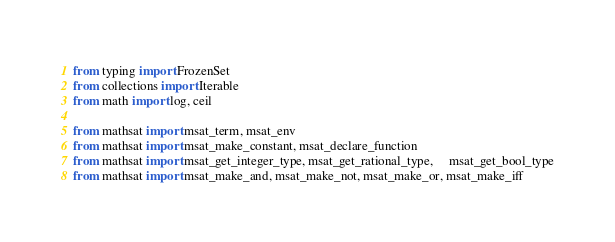Convert code to text. <code><loc_0><loc_0><loc_500><loc_500><_Python_>from typing import FrozenSet
from collections import Iterable
from math import log, ceil

from mathsat import msat_term, msat_env
from mathsat import msat_make_constant, msat_declare_function
from mathsat import msat_get_integer_type, msat_get_rational_type,     msat_get_bool_type
from mathsat import msat_make_and, msat_make_not, msat_make_or, msat_make_iff</code> 